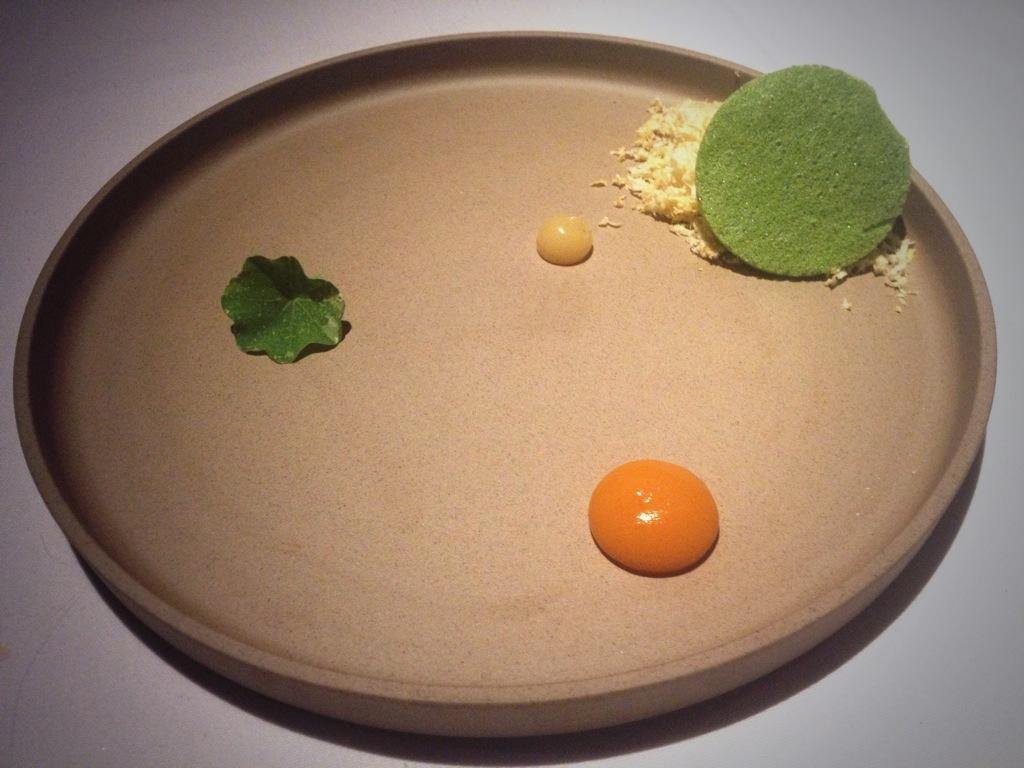What types of food items can be seen in the image? There are food items in the image, but their specific types cannot be determined without more information. What is the leaf doing in the plate? The leaf is present in the plate, but its purpose or role cannot be determined without more information. What color is the background of the image? The plate is on a white background. Can you see a plane flying over the mountain in the image? There is no plane or mountain present in the image; it only features food items, a leaf, and a white background. 